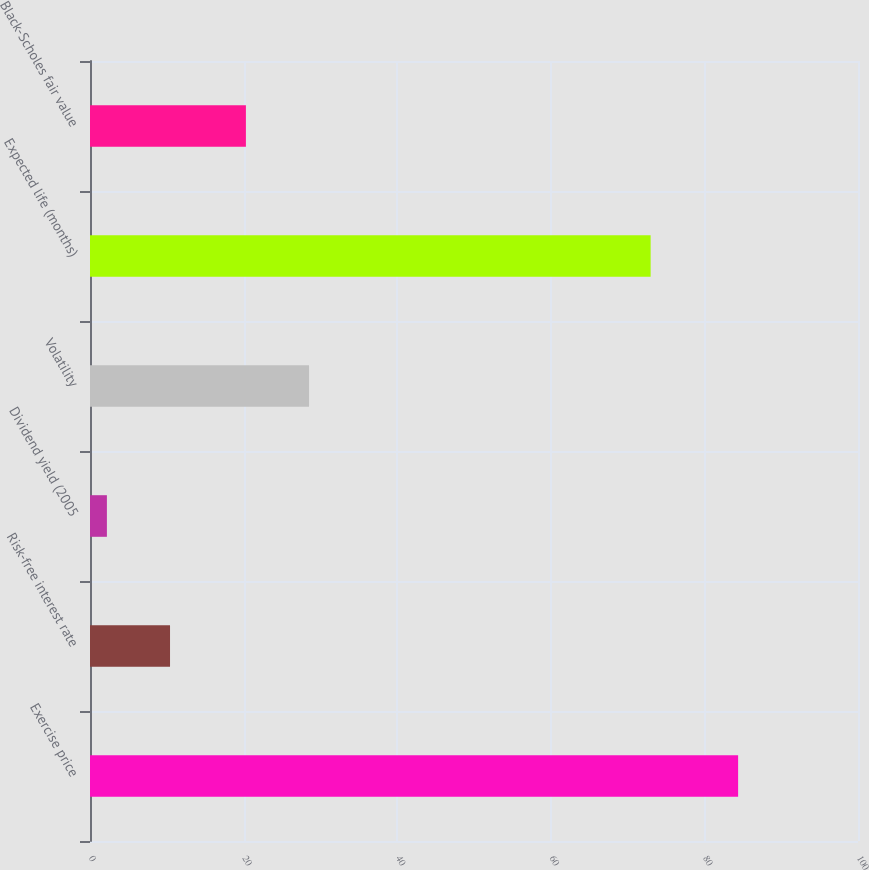Convert chart. <chart><loc_0><loc_0><loc_500><loc_500><bar_chart><fcel>Exercise price<fcel>Risk-free interest rate<fcel>Dividend yield (2005<fcel>Volatility<fcel>Expected life (months)<fcel>Black-Scholes fair value<nl><fcel>84.39<fcel>10.42<fcel>2.2<fcel>28.52<fcel>73<fcel>20.3<nl></chart> 